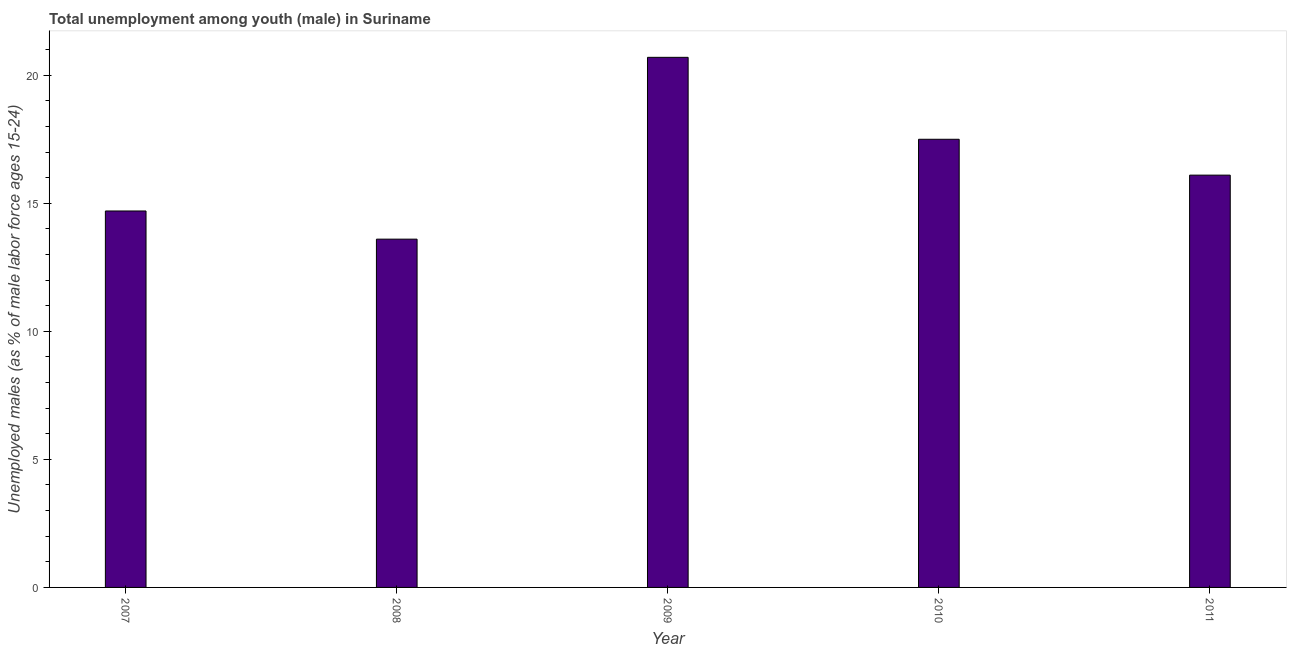Does the graph contain any zero values?
Make the answer very short. No. What is the title of the graph?
Your response must be concise. Total unemployment among youth (male) in Suriname. What is the label or title of the X-axis?
Your answer should be compact. Year. What is the label or title of the Y-axis?
Your response must be concise. Unemployed males (as % of male labor force ages 15-24). What is the unemployed male youth population in 2009?
Give a very brief answer. 20.7. Across all years, what is the maximum unemployed male youth population?
Make the answer very short. 20.7. Across all years, what is the minimum unemployed male youth population?
Offer a very short reply. 13.6. In which year was the unemployed male youth population minimum?
Give a very brief answer. 2008. What is the sum of the unemployed male youth population?
Offer a terse response. 82.6. What is the difference between the unemployed male youth population in 2007 and 2010?
Keep it short and to the point. -2.8. What is the average unemployed male youth population per year?
Make the answer very short. 16.52. What is the median unemployed male youth population?
Give a very brief answer. 16.1. In how many years, is the unemployed male youth population greater than 9 %?
Keep it short and to the point. 5. What is the ratio of the unemployed male youth population in 2008 to that in 2009?
Provide a succinct answer. 0.66. What is the difference between the highest and the second highest unemployed male youth population?
Offer a terse response. 3.2. Is the sum of the unemployed male youth population in 2008 and 2010 greater than the maximum unemployed male youth population across all years?
Provide a succinct answer. Yes. What is the difference between the highest and the lowest unemployed male youth population?
Ensure brevity in your answer.  7.1. In how many years, is the unemployed male youth population greater than the average unemployed male youth population taken over all years?
Ensure brevity in your answer.  2. How many years are there in the graph?
Offer a very short reply. 5. Are the values on the major ticks of Y-axis written in scientific E-notation?
Offer a terse response. No. What is the Unemployed males (as % of male labor force ages 15-24) in 2007?
Offer a very short reply. 14.7. What is the Unemployed males (as % of male labor force ages 15-24) in 2008?
Your answer should be compact. 13.6. What is the Unemployed males (as % of male labor force ages 15-24) of 2009?
Keep it short and to the point. 20.7. What is the Unemployed males (as % of male labor force ages 15-24) of 2011?
Offer a terse response. 16.1. What is the difference between the Unemployed males (as % of male labor force ages 15-24) in 2007 and 2010?
Make the answer very short. -2.8. What is the difference between the Unemployed males (as % of male labor force ages 15-24) in 2007 and 2011?
Give a very brief answer. -1.4. What is the difference between the Unemployed males (as % of male labor force ages 15-24) in 2009 and 2010?
Offer a terse response. 3.2. What is the difference between the Unemployed males (as % of male labor force ages 15-24) in 2009 and 2011?
Give a very brief answer. 4.6. What is the ratio of the Unemployed males (as % of male labor force ages 15-24) in 2007 to that in 2008?
Offer a very short reply. 1.08. What is the ratio of the Unemployed males (as % of male labor force ages 15-24) in 2007 to that in 2009?
Provide a succinct answer. 0.71. What is the ratio of the Unemployed males (as % of male labor force ages 15-24) in 2007 to that in 2010?
Offer a very short reply. 0.84. What is the ratio of the Unemployed males (as % of male labor force ages 15-24) in 2008 to that in 2009?
Ensure brevity in your answer.  0.66. What is the ratio of the Unemployed males (as % of male labor force ages 15-24) in 2008 to that in 2010?
Your response must be concise. 0.78. What is the ratio of the Unemployed males (as % of male labor force ages 15-24) in 2008 to that in 2011?
Offer a very short reply. 0.84. What is the ratio of the Unemployed males (as % of male labor force ages 15-24) in 2009 to that in 2010?
Give a very brief answer. 1.18. What is the ratio of the Unemployed males (as % of male labor force ages 15-24) in 2009 to that in 2011?
Ensure brevity in your answer.  1.29. What is the ratio of the Unemployed males (as % of male labor force ages 15-24) in 2010 to that in 2011?
Provide a short and direct response. 1.09. 